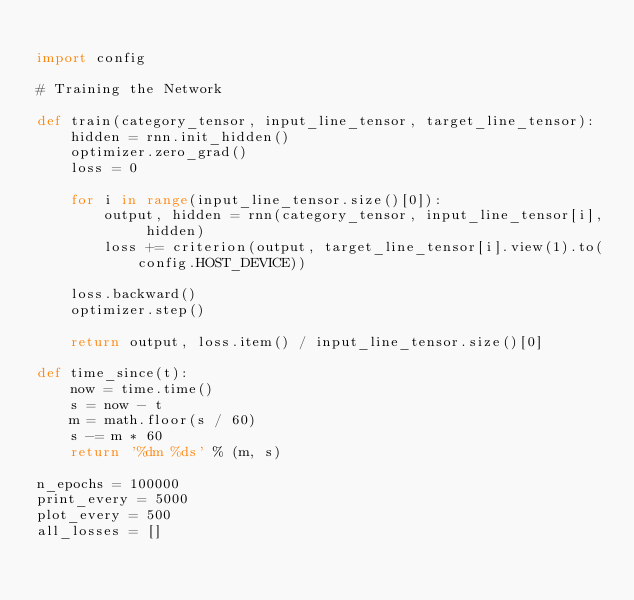Convert code to text. <code><loc_0><loc_0><loc_500><loc_500><_Python_>
import config

# Training the Network

def train(category_tensor, input_line_tensor, target_line_tensor):
    hidden = rnn.init_hidden()
    optimizer.zero_grad()
    loss = 0
    
    for i in range(input_line_tensor.size()[0]):
        output, hidden = rnn(category_tensor, input_line_tensor[i], hidden)
        loss += criterion(output, target_line_tensor[i].view(1).to(config.HOST_DEVICE))

    loss.backward()
    optimizer.step()
    
    return output, loss.item() / input_line_tensor.size()[0]

def time_since(t):
    now = time.time()
    s = now - t
    m = math.floor(s / 60)
    s -= m * 60
    return '%dm %ds' % (m, s)

n_epochs = 100000
print_every = 5000
plot_every = 500
all_losses = []</code> 